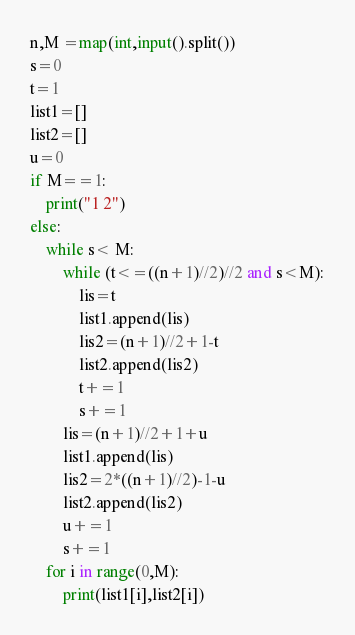Convert code to text. <code><loc_0><loc_0><loc_500><loc_500><_Python_>n,M =map(int,input().split())
s=0
t=1
list1=[]
list2=[]
u=0
if M==1:
    print("1 2")
else:    
    while s< M:
        while (t<=((n+1)//2)//2 and s<M):
            lis=t
            list1.append(lis)
            lis2=(n+1)//2+1-t
            list2.append(lis2)
            t+=1
            s+=1
        lis=(n+1)//2+1+u
        list1.append(lis)
        lis2=2*((n+1)//2)-1-u
        list2.append(lis2)
        u+=1
        s+=1
    for i in range(0,M):
        print(list1[i],list2[i])</code> 